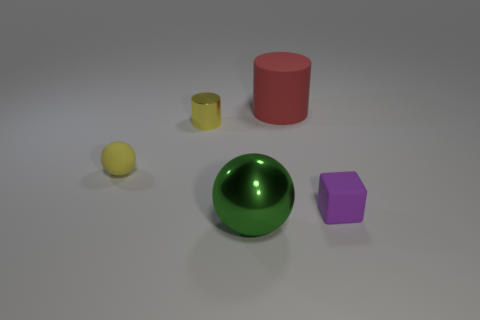Are there any other things that have the same shape as the purple thing?
Ensure brevity in your answer.  No. There is a purple cube that is the same material as the yellow sphere; what is its size?
Ensure brevity in your answer.  Small. There is a yellow object on the right side of the sphere behind the metallic thing that is in front of the tiny cylinder; what size is it?
Your answer should be very brief. Small. What is the color of the thing that is on the left side of the small cylinder?
Keep it short and to the point. Yellow. Is the number of matte blocks that are behind the green thing greater than the number of big purple cylinders?
Keep it short and to the point. Yes. Do the big object that is behind the tiny purple thing and the yellow shiny thing have the same shape?
Make the answer very short. Yes. What number of green objects are big rubber things or tiny rubber balls?
Provide a short and direct response. 0. Are there more tiny yellow things than tiny purple rubber cubes?
Ensure brevity in your answer.  Yes. The shiny sphere that is the same size as the red cylinder is what color?
Provide a short and direct response. Green. What number of cylinders are big matte objects or yellow objects?
Provide a succinct answer. 2. 